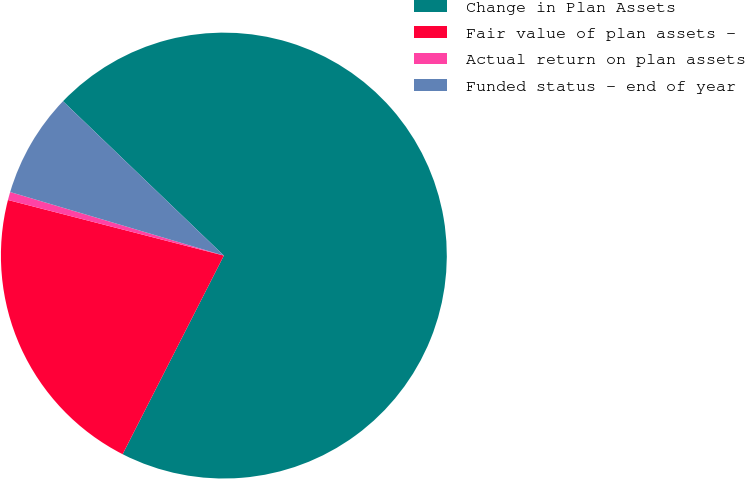Convert chart. <chart><loc_0><loc_0><loc_500><loc_500><pie_chart><fcel>Change in Plan Assets<fcel>Fair value of plan assets -<fcel>Actual return on plan assets<fcel>Funded status - end of year<nl><fcel>70.33%<fcel>21.51%<fcel>0.59%<fcel>7.57%<nl></chart> 